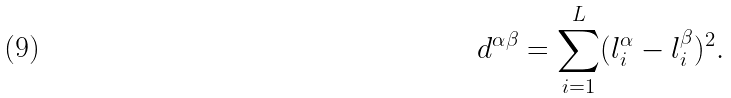Convert formula to latex. <formula><loc_0><loc_0><loc_500><loc_500>d ^ { \alpha \beta } = \sum _ { i = 1 } ^ { L } ( l _ { i } ^ { \alpha } - l _ { i } ^ { \beta } ) ^ { 2 } .</formula> 